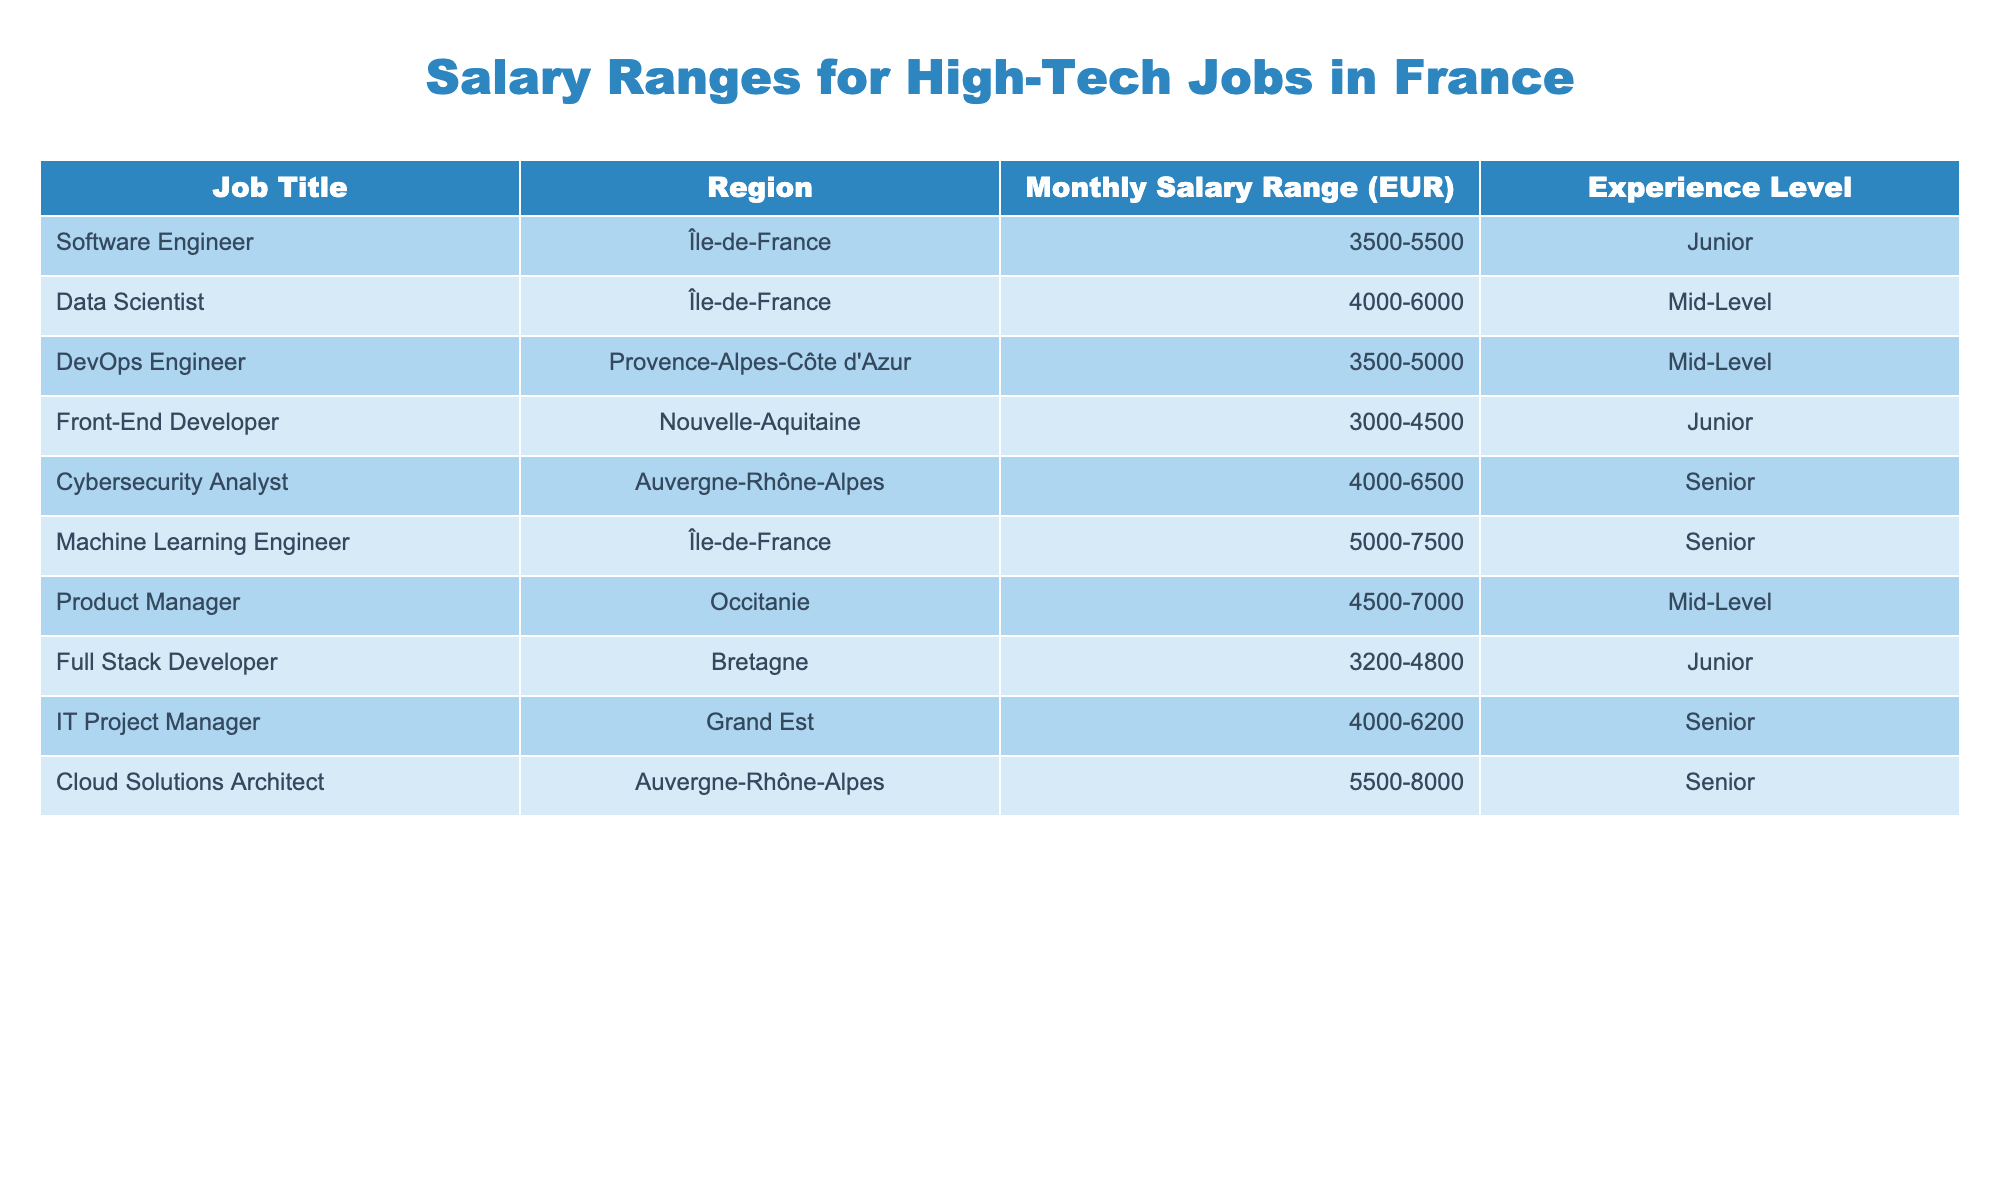What is the highest monthly salary range for a high-tech job in France? The table reveals that the highest monthly salary range is for the Cloud Solutions Architect in the Auvergne-Rhône-Alpes region, which is 5500-8000 EUR.
Answer: 5500-8000 EUR Which region has the lowest salary range for junior-level positions? The Front-End Developer in the Nouvelle-Aquitaine region has the lowest salary range for junior-level positions at 3000-4500 EUR.
Answer: 3000-4500 EUR Is the monthly salary range higher for senior-level positions compared to junior-level positions? By comparing the salary ranges, the highest for seniors is 5500-8000 EUR (Cloud Solutions Architect), while juniors max out at 3500-5500 EUR. Thus, senior salaries are higher.
Answer: Yes What is the average monthly salary range for mid-level positions? The ranges for mid-level positions (Data Scientist, DevOps Engineer, and Product Manager) are 4000-6000, 3500-5000, and 4500-7000 EUR respectively. Calculating the midpoints gives: (4750 + 4250 + 5750) / 3 = 4750 EUR.
Answer: 4750 EUR Which job title has the largest salary range? By checking the salary ranges, the Cloud Solutions Architect has a range of 5500-8000 EUR, making it the largest in the table.
Answer: Cloud Solutions Architect How many job titles have a salary range exceeding 5000 EUR for senior roles? The job titles with salary ranges exceeding 5000 EUR for senior roles are the Cybersecurity Analyst and Cloud Solutions Architect. Therefore, there are two such titles.
Answer: 2 What is the total monthly salary range (in EUR) for all junior-level positions in the table? The ranges for junior positions are 3500-5500, 3000-4500, and 3200-4800 EUR. Sum the lower limits (3500 + 3000 + 3200 = 9700) and the upper limits (5500 + 4500 + 4800 = 14800), resulting in a total range of 9700-14800 EUR.
Answer: 9700-14800 EUR What is the difference between the highest and lowest monthly salary ranges for the jobs listed? The highest range is 5500-8000 EUR, and the lowest is 3000-4500 EUR. The difference between their lower limits is 5500 - 3000 = 2500 EUR and between upper limits is 8000 - 4500 = 3500 EUR. So the difference is 2500-3500 EUR.
Answer: 2500-3500 EUR 